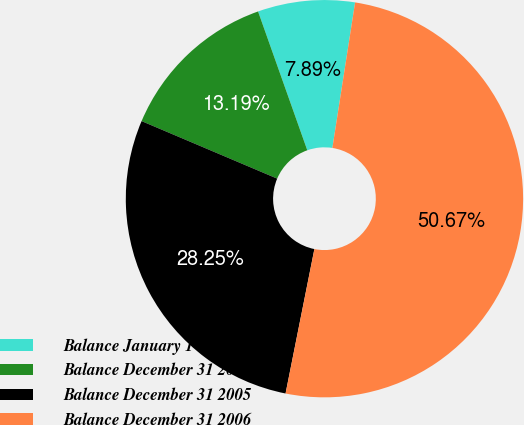<chart> <loc_0><loc_0><loc_500><loc_500><pie_chart><fcel>Balance January 1 2004<fcel>Balance December 31 2004<fcel>Balance December 31 2005<fcel>Balance December 31 2006<nl><fcel>7.89%<fcel>13.19%<fcel>28.25%<fcel>50.67%<nl></chart> 